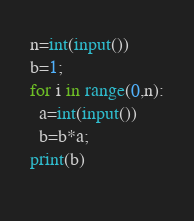Convert code to text. <code><loc_0><loc_0><loc_500><loc_500><_Python_>n=int(input())
b=1;
for i in range(0,n):
  a=int(input())
  b=b*a;
print(b)  
  </code> 